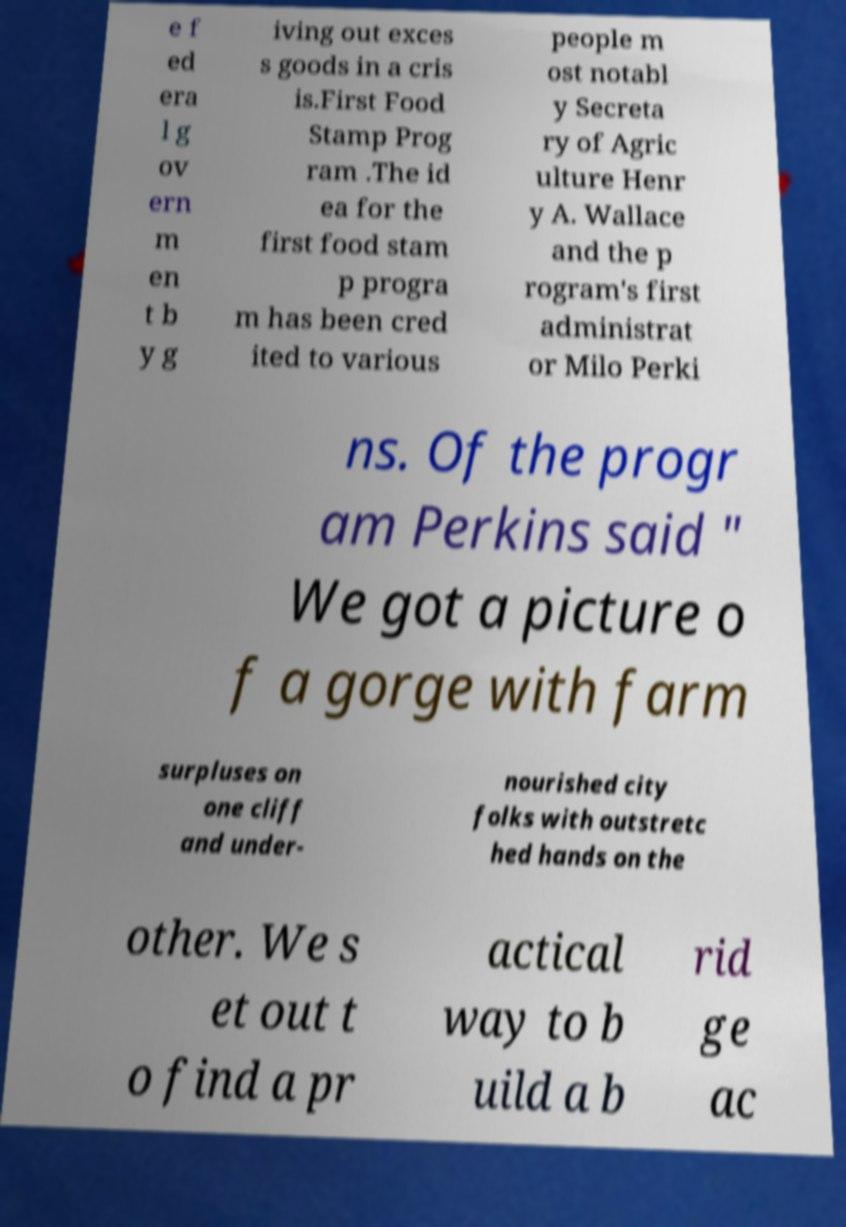For documentation purposes, I need the text within this image transcribed. Could you provide that? e f ed era l g ov ern m en t b y g iving out exces s goods in a cris is.First Food Stamp Prog ram .The id ea for the first food stam p progra m has been cred ited to various people m ost notabl y Secreta ry of Agric ulture Henr y A. Wallace and the p rogram's first administrat or Milo Perki ns. Of the progr am Perkins said " We got a picture o f a gorge with farm surpluses on one cliff and under- nourished city folks with outstretc hed hands on the other. We s et out t o find a pr actical way to b uild a b rid ge ac 